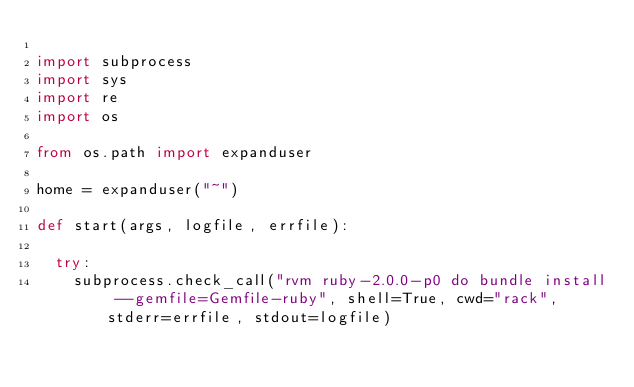<code> <loc_0><loc_0><loc_500><loc_500><_Python_>
import subprocess
import sys
import re
import os

from os.path import expanduser

home = expanduser("~")

def start(args, logfile, errfile):

  try:
    subprocess.check_call("rvm ruby-2.0.0-p0 do bundle install --gemfile=Gemfile-ruby", shell=True, cwd="rack", stderr=errfile, stdout=logfile)</code> 